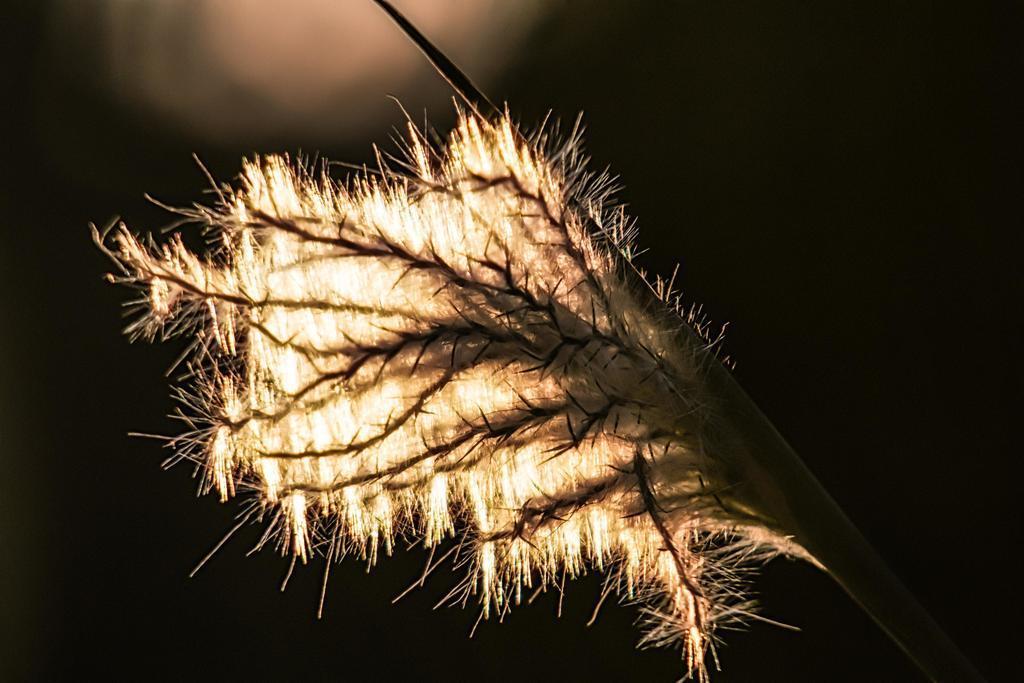Please provide a concise description of this image. In this image may be there is a flower, on which there are thorns, stem visible, background is dark. 